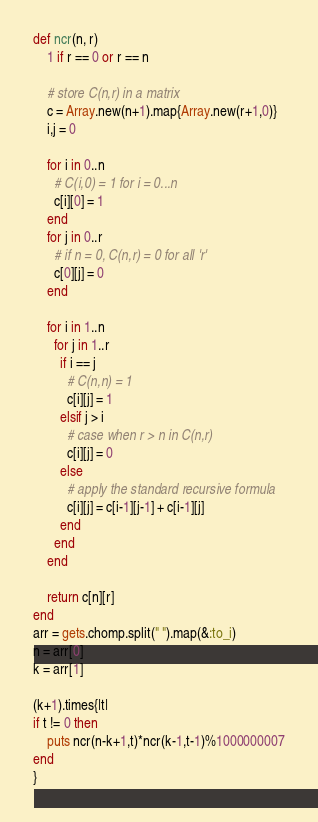Convert code to text. <code><loc_0><loc_0><loc_500><loc_500><_Ruby_>def ncr(n, r)
    1 if r == 0 or r == n
  
    # store C(n,r) in a matrix
    c = Array.new(n+1).map{Array.new(r+1,0)}
    i,j = 0
  
    for i in 0..n
      # C(i,0) = 1 for i = 0...n
      c[i][0] = 1
    end
    for j in 0..r
      # if n = 0, C(n,r) = 0 for all 'r'
      c[0][j] = 0
    end
  
    for i in 1..n
      for j in 1..r
        if i == j
          # C(n,n) = 1
          c[i][j] = 1
        elsif j > i
          # case when r > n in C(n,r)
          c[i][j] = 0
        else
          # apply the standard recursive formula
          c[i][j] = c[i-1][j-1] + c[i-1][j]
        end
      end
    end
  
    return c[n][r]
end
arr = gets.chomp.split(" ").map(&:to_i)
n = arr[0]
k = arr[1]

(k+1).times{|t|
if t != 0 then
    puts ncr(n-k+1,t)*ncr(k-1,t-1)%1000000007
end
}</code> 